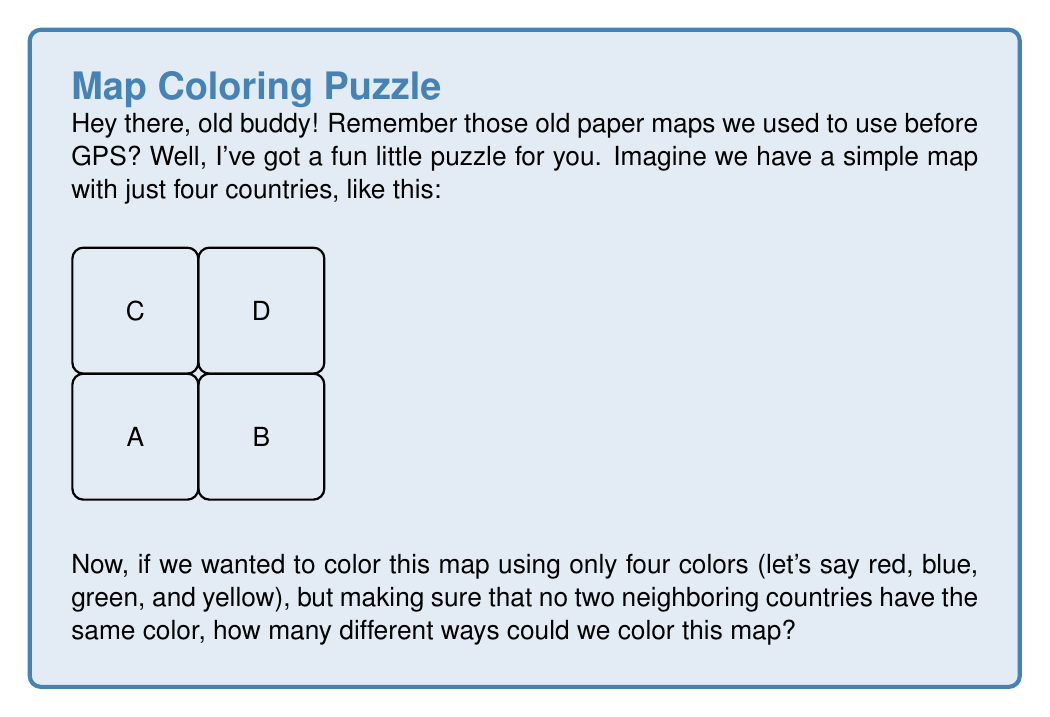Teach me how to tackle this problem. Alright, let's think this through step-by-step:

1) First, we need to understand what "different ways" means. Two colorings are different if at least one country has a different color in the two colorings.

2) Let's start with country A. We have 4 color choices for A, so let's pick one.

3) Now, for country B, we can't use the same color as A, so we have 3 choices.

4) For country C, we can't use A's color, but we could use B's color if we wanted. So we have 3 choices for C.

5) Finally, for country D, we can't use B's or C's colors, but we could use A's color if it's not already used by C. So we have either 2 or 3 choices for D, depending on what we chose for C.

6) Now, let's count:
   - We have 4 choices for A
   - For each choice of A, we have 3 choices for B
   - For each choice of A and B, we have 3 choices for C
   - For each choice of A, B, and C, we have at least 2 choices for D

7) Therefore, the total number of colorings is at least:

   $$4 \times 3 \times 3 \times 2 = 72$$

8) In fact, this is exactly the number of colorings, because in every case, we will have exactly 2 choices for D (either A's color if it's not used by C, or the one remaining color).

So, there are 72 different ways to color this map using four colors.
Answer: 72 